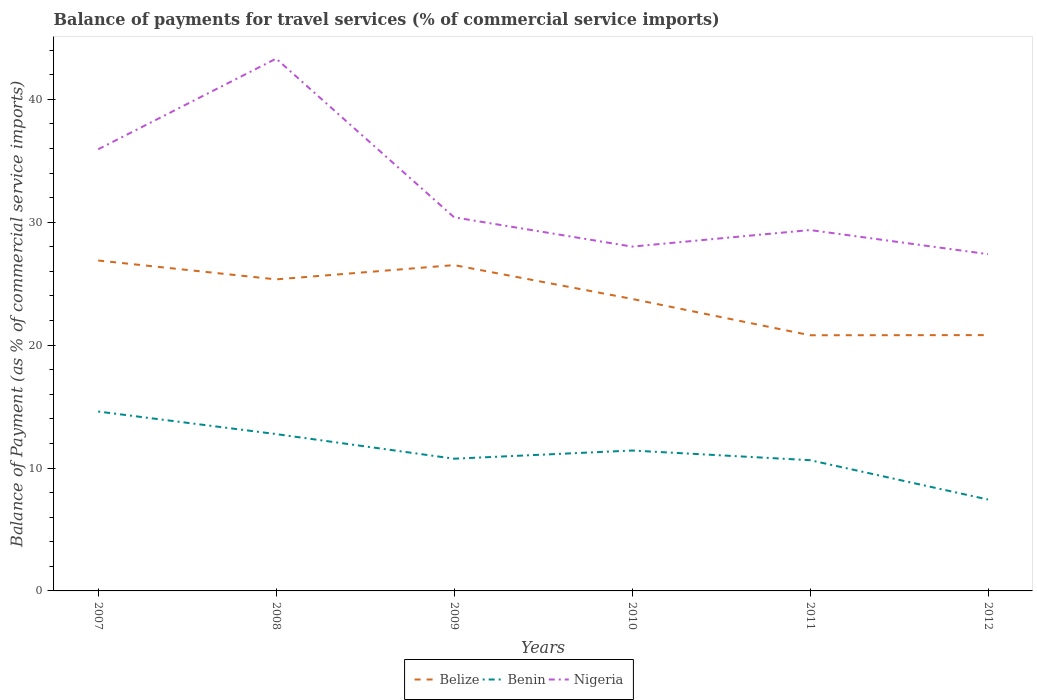How many different coloured lines are there?
Give a very brief answer. 3. Does the line corresponding to Belize intersect with the line corresponding to Benin?
Make the answer very short. No. Across all years, what is the maximum balance of payments for travel services in Benin?
Your response must be concise. 7.44. What is the total balance of payments for travel services in Benin in the graph?
Offer a very short reply. 0.79. What is the difference between the highest and the second highest balance of payments for travel services in Belize?
Keep it short and to the point. 6.08. What is the difference between the highest and the lowest balance of payments for travel services in Benin?
Give a very brief answer. 3. Is the balance of payments for travel services in Benin strictly greater than the balance of payments for travel services in Belize over the years?
Ensure brevity in your answer.  Yes. How many lines are there?
Make the answer very short. 3. What is the difference between two consecutive major ticks on the Y-axis?
Offer a very short reply. 10. How are the legend labels stacked?
Your response must be concise. Horizontal. What is the title of the graph?
Offer a very short reply. Balance of payments for travel services (% of commercial service imports). What is the label or title of the Y-axis?
Give a very brief answer. Balance of Payment (as % of commercial service imports). What is the Balance of Payment (as % of commercial service imports) of Belize in 2007?
Provide a short and direct response. 26.89. What is the Balance of Payment (as % of commercial service imports) in Benin in 2007?
Make the answer very short. 14.6. What is the Balance of Payment (as % of commercial service imports) in Nigeria in 2007?
Your response must be concise. 35.94. What is the Balance of Payment (as % of commercial service imports) of Belize in 2008?
Provide a short and direct response. 25.35. What is the Balance of Payment (as % of commercial service imports) in Benin in 2008?
Your answer should be compact. 12.76. What is the Balance of Payment (as % of commercial service imports) of Nigeria in 2008?
Your answer should be compact. 43.31. What is the Balance of Payment (as % of commercial service imports) in Belize in 2009?
Offer a terse response. 26.51. What is the Balance of Payment (as % of commercial service imports) in Benin in 2009?
Your response must be concise. 10.76. What is the Balance of Payment (as % of commercial service imports) of Nigeria in 2009?
Give a very brief answer. 30.4. What is the Balance of Payment (as % of commercial service imports) in Belize in 2010?
Make the answer very short. 23.76. What is the Balance of Payment (as % of commercial service imports) in Benin in 2010?
Your answer should be compact. 11.42. What is the Balance of Payment (as % of commercial service imports) in Nigeria in 2010?
Your response must be concise. 28.02. What is the Balance of Payment (as % of commercial service imports) of Belize in 2011?
Your answer should be very brief. 20.8. What is the Balance of Payment (as % of commercial service imports) in Benin in 2011?
Keep it short and to the point. 10.64. What is the Balance of Payment (as % of commercial service imports) in Nigeria in 2011?
Provide a short and direct response. 29.37. What is the Balance of Payment (as % of commercial service imports) in Belize in 2012?
Offer a very short reply. 20.82. What is the Balance of Payment (as % of commercial service imports) in Benin in 2012?
Provide a succinct answer. 7.44. What is the Balance of Payment (as % of commercial service imports) of Nigeria in 2012?
Offer a very short reply. 27.4. Across all years, what is the maximum Balance of Payment (as % of commercial service imports) of Belize?
Provide a short and direct response. 26.89. Across all years, what is the maximum Balance of Payment (as % of commercial service imports) of Benin?
Ensure brevity in your answer.  14.6. Across all years, what is the maximum Balance of Payment (as % of commercial service imports) of Nigeria?
Keep it short and to the point. 43.31. Across all years, what is the minimum Balance of Payment (as % of commercial service imports) in Belize?
Give a very brief answer. 20.8. Across all years, what is the minimum Balance of Payment (as % of commercial service imports) in Benin?
Provide a short and direct response. 7.44. Across all years, what is the minimum Balance of Payment (as % of commercial service imports) of Nigeria?
Provide a succinct answer. 27.4. What is the total Balance of Payment (as % of commercial service imports) in Belize in the graph?
Make the answer very short. 144.13. What is the total Balance of Payment (as % of commercial service imports) in Benin in the graph?
Ensure brevity in your answer.  67.62. What is the total Balance of Payment (as % of commercial service imports) of Nigeria in the graph?
Offer a very short reply. 194.43. What is the difference between the Balance of Payment (as % of commercial service imports) in Belize in 2007 and that in 2008?
Ensure brevity in your answer.  1.54. What is the difference between the Balance of Payment (as % of commercial service imports) in Benin in 2007 and that in 2008?
Provide a succinct answer. 1.84. What is the difference between the Balance of Payment (as % of commercial service imports) of Nigeria in 2007 and that in 2008?
Offer a terse response. -7.38. What is the difference between the Balance of Payment (as % of commercial service imports) of Belize in 2007 and that in 2009?
Offer a very short reply. 0.37. What is the difference between the Balance of Payment (as % of commercial service imports) in Benin in 2007 and that in 2009?
Offer a very short reply. 3.84. What is the difference between the Balance of Payment (as % of commercial service imports) of Nigeria in 2007 and that in 2009?
Your answer should be compact. 5.54. What is the difference between the Balance of Payment (as % of commercial service imports) of Belize in 2007 and that in 2010?
Your response must be concise. 3.13. What is the difference between the Balance of Payment (as % of commercial service imports) in Benin in 2007 and that in 2010?
Ensure brevity in your answer.  3.17. What is the difference between the Balance of Payment (as % of commercial service imports) in Nigeria in 2007 and that in 2010?
Give a very brief answer. 7.92. What is the difference between the Balance of Payment (as % of commercial service imports) in Belize in 2007 and that in 2011?
Ensure brevity in your answer.  6.08. What is the difference between the Balance of Payment (as % of commercial service imports) in Benin in 2007 and that in 2011?
Keep it short and to the point. 3.96. What is the difference between the Balance of Payment (as % of commercial service imports) of Nigeria in 2007 and that in 2011?
Make the answer very short. 6.57. What is the difference between the Balance of Payment (as % of commercial service imports) in Belize in 2007 and that in 2012?
Offer a terse response. 6.07. What is the difference between the Balance of Payment (as % of commercial service imports) of Benin in 2007 and that in 2012?
Offer a terse response. 7.16. What is the difference between the Balance of Payment (as % of commercial service imports) of Nigeria in 2007 and that in 2012?
Provide a succinct answer. 8.53. What is the difference between the Balance of Payment (as % of commercial service imports) in Belize in 2008 and that in 2009?
Provide a short and direct response. -1.16. What is the difference between the Balance of Payment (as % of commercial service imports) in Benin in 2008 and that in 2009?
Provide a succinct answer. 2. What is the difference between the Balance of Payment (as % of commercial service imports) in Nigeria in 2008 and that in 2009?
Keep it short and to the point. 12.91. What is the difference between the Balance of Payment (as % of commercial service imports) of Belize in 2008 and that in 2010?
Your answer should be compact. 1.59. What is the difference between the Balance of Payment (as % of commercial service imports) in Benin in 2008 and that in 2010?
Keep it short and to the point. 1.34. What is the difference between the Balance of Payment (as % of commercial service imports) of Nigeria in 2008 and that in 2010?
Offer a very short reply. 15.3. What is the difference between the Balance of Payment (as % of commercial service imports) of Belize in 2008 and that in 2011?
Ensure brevity in your answer.  4.55. What is the difference between the Balance of Payment (as % of commercial service imports) in Benin in 2008 and that in 2011?
Your answer should be very brief. 2.12. What is the difference between the Balance of Payment (as % of commercial service imports) in Nigeria in 2008 and that in 2011?
Your answer should be compact. 13.95. What is the difference between the Balance of Payment (as % of commercial service imports) in Belize in 2008 and that in 2012?
Your answer should be very brief. 4.53. What is the difference between the Balance of Payment (as % of commercial service imports) in Benin in 2008 and that in 2012?
Provide a succinct answer. 5.32. What is the difference between the Balance of Payment (as % of commercial service imports) of Nigeria in 2008 and that in 2012?
Your answer should be compact. 15.91. What is the difference between the Balance of Payment (as % of commercial service imports) of Belize in 2009 and that in 2010?
Provide a short and direct response. 2.75. What is the difference between the Balance of Payment (as % of commercial service imports) of Benin in 2009 and that in 2010?
Ensure brevity in your answer.  -0.67. What is the difference between the Balance of Payment (as % of commercial service imports) in Nigeria in 2009 and that in 2010?
Ensure brevity in your answer.  2.38. What is the difference between the Balance of Payment (as % of commercial service imports) of Belize in 2009 and that in 2011?
Provide a short and direct response. 5.71. What is the difference between the Balance of Payment (as % of commercial service imports) in Benin in 2009 and that in 2011?
Provide a succinct answer. 0.12. What is the difference between the Balance of Payment (as % of commercial service imports) of Nigeria in 2009 and that in 2011?
Offer a terse response. 1.03. What is the difference between the Balance of Payment (as % of commercial service imports) of Belize in 2009 and that in 2012?
Ensure brevity in your answer.  5.7. What is the difference between the Balance of Payment (as % of commercial service imports) of Benin in 2009 and that in 2012?
Offer a very short reply. 3.32. What is the difference between the Balance of Payment (as % of commercial service imports) in Nigeria in 2009 and that in 2012?
Offer a terse response. 3. What is the difference between the Balance of Payment (as % of commercial service imports) in Belize in 2010 and that in 2011?
Keep it short and to the point. 2.96. What is the difference between the Balance of Payment (as % of commercial service imports) of Benin in 2010 and that in 2011?
Provide a succinct answer. 0.79. What is the difference between the Balance of Payment (as % of commercial service imports) in Nigeria in 2010 and that in 2011?
Give a very brief answer. -1.35. What is the difference between the Balance of Payment (as % of commercial service imports) in Belize in 2010 and that in 2012?
Your answer should be compact. 2.94. What is the difference between the Balance of Payment (as % of commercial service imports) in Benin in 2010 and that in 2012?
Your answer should be very brief. 3.99. What is the difference between the Balance of Payment (as % of commercial service imports) of Nigeria in 2010 and that in 2012?
Ensure brevity in your answer.  0.61. What is the difference between the Balance of Payment (as % of commercial service imports) in Belize in 2011 and that in 2012?
Keep it short and to the point. -0.01. What is the difference between the Balance of Payment (as % of commercial service imports) of Benin in 2011 and that in 2012?
Provide a short and direct response. 3.2. What is the difference between the Balance of Payment (as % of commercial service imports) of Nigeria in 2011 and that in 2012?
Give a very brief answer. 1.96. What is the difference between the Balance of Payment (as % of commercial service imports) of Belize in 2007 and the Balance of Payment (as % of commercial service imports) of Benin in 2008?
Give a very brief answer. 14.12. What is the difference between the Balance of Payment (as % of commercial service imports) in Belize in 2007 and the Balance of Payment (as % of commercial service imports) in Nigeria in 2008?
Offer a terse response. -16.43. What is the difference between the Balance of Payment (as % of commercial service imports) in Benin in 2007 and the Balance of Payment (as % of commercial service imports) in Nigeria in 2008?
Keep it short and to the point. -28.72. What is the difference between the Balance of Payment (as % of commercial service imports) in Belize in 2007 and the Balance of Payment (as % of commercial service imports) in Benin in 2009?
Keep it short and to the point. 16.13. What is the difference between the Balance of Payment (as % of commercial service imports) in Belize in 2007 and the Balance of Payment (as % of commercial service imports) in Nigeria in 2009?
Make the answer very short. -3.51. What is the difference between the Balance of Payment (as % of commercial service imports) in Benin in 2007 and the Balance of Payment (as % of commercial service imports) in Nigeria in 2009?
Provide a succinct answer. -15.8. What is the difference between the Balance of Payment (as % of commercial service imports) in Belize in 2007 and the Balance of Payment (as % of commercial service imports) in Benin in 2010?
Ensure brevity in your answer.  15.46. What is the difference between the Balance of Payment (as % of commercial service imports) in Belize in 2007 and the Balance of Payment (as % of commercial service imports) in Nigeria in 2010?
Keep it short and to the point. -1.13. What is the difference between the Balance of Payment (as % of commercial service imports) of Benin in 2007 and the Balance of Payment (as % of commercial service imports) of Nigeria in 2010?
Make the answer very short. -13.42. What is the difference between the Balance of Payment (as % of commercial service imports) of Belize in 2007 and the Balance of Payment (as % of commercial service imports) of Benin in 2011?
Provide a succinct answer. 16.25. What is the difference between the Balance of Payment (as % of commercial service imports) in Belize in 2007 and the Balance of Payment (as % of commercial service imports) in Nigeria in 2011?
Your answer should be compact. -2.48. What is the difference between the Balance of Payment (as % of commercial service imports) of Benin in 2007 and the Balance of Payment (as % of commercial service imports) of Nigeria in 2011?
Keep it short and to the point. -14.77. What is the difference between the Balance of Payment (as % of commercial service imports) of Belize in 2007 and the Balance of Payment (as % of commercial service imports) of Benin in 2012?
Keep it short and to the point. 19.45. What is the difference between the Balance of Payment (as % of commercial service imports) of Belize in 2007 and the Balance of Payment (as % of commercial service imports) of Nigeria in 2012?
Ensure brevity in your answer.  -0.52. What is the difference between the Balance of Payment (as % of commercial service imports) in Benin in 2007 and the Balance of Payment (as % of commercial service imports) in Nigeria in 2012?
Keep it short and to the point. -12.81. What is the difference between the Balance of Payment (as % of commercial service imports) in Belize in 2008 and the Balance of Payment (as % of commercial service imports) in Benin in 2009?
Give a very brief answer. 14.59. What is the difference between the Balance of Payment (as % of commercial service imports) of Belize in 2008 and the Balance of Payment (as % of commercial service imports) of Nigeria in 2009?
Offer a terse response. -5.05. What is the difference between the Balance of Payment (as % of commercial service imports) in Benin in 2008 and the Balance of Payment (as % of commercial service imports) in Nigeria in 2009?
Your answer should be very brief. -17.64. What is the difference between the Balance of Payment (as % of commercial service imports) in Belize in 2008 and the Balance of Payment (as % of commercial service imports) in Benin in 2010?
Offer a terse response. 13.93. What is the difference between the Balance of Payment (as % of commercial service imports) of Belize in 2008 and the Balance of Payment (as % of commercial service imports) of Nigeria in 2010?
Your answer should be compact. -2.67. What is the difference between the Balance of Payment (as % of commercial service imports) in Benin in 2008 and the Balance of Payment (as % of commercial service imports) in Nigeria in 2010?
Offer a terse response. -15.26. What is the difference between the Balance of Payment (as % of commercial service imports) of Belize in 2008 and the Balance of Payment (as % of commercial service imports) of Benin in 2011?
Keep it short and to the point. 14.71. What is the difference between the Balance of Payment (as % of commercial service imports) of Belize in 2008 and the Balance of Payment (as % of commercial service imports) of Nigeria in 2011?
Make the answer very short. -4.02. What is the difference between the Balance of Payment (as % of commercial service imports) of Benin in 2008 and the Balance of Payment (as % of commercial service imports) of Nigeria in 2011?
Offer a terse response. -16.6. What is the difference between the Balance of Payment (as % of commercial service imports) in Belize in 2008 and the Balance of Payment (as % of commercial service imports) in Benin in 2012?
Provide a short and direct response. 17.91. What is the difference between the Balance of Payment (as % of commercial service imports) in Belize in 2008 and the Balance of Payment (as % of commercial service imports) in Nigeria in 2012?
Keep it short and to the point. -2.05. What is the difference between the Balance of Payment (as % of commercial service imports) of Benin in 2008 and the Balance of Payment (as % of commercial service imports) of Nigeria in 2012?
Your response must be concise. -14.64. What is the difference between the Balance of Payment (as % of commercial service imports) of Belize in 2009 and the Balance of Payment (as % of commercial service imports) of Benin in 2010?
Make the answer very short. 15.09. What is the difference between the Balance of Payment (as % of commercial service imports) of Belize in 2009 and the Balance of Payment (as % of commercial service imports) of Nigeria in 2010?
Your answer should be very brief. -1.5. What is the difference between the Balance of Payment (as % of commercial service imports) of Benin in 2009 and the Balance of Payment (as % of commercial service imports) of Nigeria in 2010?
Provide a short and direct response. -17.26. What is the difference between the Balance of Payment (as % of commercial service imports) of Belize in 2009 and the Balance of Payment (as % of commercial service imports) of Benin in 2011?
Ensure brevity in your answer.  15.87. What is the difference between the Balance of Payment (as % of commercial service imports) of Belize in 2009 and the Balance of Payment (as % of commercial service imports) of Nigeria in 2011?
Offer a very short reply. -2.85. What is the difference between the Balance of Payment (as % of commercial service imports) of Benin in 2009 and the Balance of Payment (as % of commercial service imports) of Nigeria in 2011?
Offer a terse response. -18.61. What is the difference between the Balance of Payment (as % of commercial service imports) of Belize in 2009 and the Balance of Payment (as % of commercial service imports) of Benin in 2012?
Offer a very short reply. 19.08. What is the difference between the Balance of Payment (as % of commercial service imports) of Belize in 2009 and the Balance of Payment (as % of commercial service imports) of Nigeria in 2012?
Make the answer very short. -0.89. What is the difference between the Balance of Payment (as % of commercial service imports) of Benin in 2009 and the Balance of Payment (as % of commercial service imports) of Nigeria in 2012?
Offer a terse response. -16.65. What is the difference between the Balance of Payment (as % of commercial service imports) in Belize in 2010 and the Balance of Payment (as % of commercial service imports) in Benin in 2011?
Provide a short and direct response. 13.12. What is the difference between the Balance of Payment (as % of commercial service imports) of Belize in 2010 and the Balance of Payment (as % of commercial service imports) of Nigeria in 2011?
Your answer should be very brief. -5.61. What is the difference between the Balance of Payment (as % of commercial service imports) in Benin in 2010 and the Balance of Payment (as % of commercial service imports) in Nigeria in 2011?
Provide a short and direct response. -17.94. What is the difference between the Balance of Payment (as % of commercial service imports) of Belize in 2010 and the Balance of Payment (as % of commercial service imports) of Benin in 2012?
Keep it short and to the point. 16.32. What is the difference between the Balance of Payment (as % of commercial service imports) in Belize in 2010 and the Balance of Payment (as % of commercial service imports) in Nigeria in 2012?
Provide a succinct answer. -3.64. What is the difference between the Balance of Payment (as % of commercial service imports) in Benin in 2010 and the Balance of Payment (as % of commercial service imports) in Nigeria in 2012?
Keep it short and to the point. -15.98. What is the difference between the Balance of Payment (as % of commercial service imports) in Belize in 2011 and the Balance of Payment (as % of commercial service imports) in Benin in 2012?
Make the answer very short. 13.37. What is the difference between the Balance of Payment (as % of commercial service imports) in Belize in 2011 and the Balance of Payment (as % of commercial service imports) in Nigeria in 2012?
Your response must be concise. -6.6. What is the difference between the Balance of Payment (as % of commercial service imports) in Benin in 2011 and the Balance of Payment (as % of commercial service imports) in Nigeria in 2012?
Your response must be concise. -16.77. What is the average Balance of Payment (as % of commercial service imports) in Belize per year?
Ensure brevity in your answer.  24.02. What is the average Balance of Payment (as % of commercial service imports) in Benin per year?
Your answer should be very brief. 11.27. What is the average Balance of Payment (as % of commercial service imports) in Nigeria per year?
Provide a short and direct response. 32.41. In the year 2007, what is the difference between the Balance of Payment (as % of commercial service imports) in Belize and Balance of Payment (as % of commercial service imports) in Benin?
Ensure brevity in your answer.  12.29. In the year 2007, what is the difference between the Balance of Payment (as % of commercial service imports) of Belize and Balance of Payment (as % of commercial service imports) of Nigeria?
Make the answer very short. -9.05. In the year 2007, what is the difference between the Balance of Payment (as % of commercial service imports) in Benin and Balance of Payment (as % of commercial service imports) in Nigeria?
Provide a short and direct response. -21.34. In the year 2008, what is the difference between the Balance of Payment (as % of commercial service imports) of Belize and Balance of Payment (as % of commercial service imports) of Benin?
Give a very brief answer. 12.59. In the year 2008, what is the difference between the Balance of Payment (as % of commercial service imports) in Belize and Balance of Payment (as % of commercial service imports) in Nigeria?
Ensure brevity in your answer.  -17.96. In the year 2008, what is the difference between the Balance of Payment (as % of commercial service imports) in Benin and Balance of Payment (as % of commercial service imports) in Nigeria?
Make the answer very short. -30.55. In the year 2009, what is the difference between the Balance of Payment (as % of commercial service imports) of Belize and Balance of Payment (as % of commercial service imports) of Benin?
Offer a very short reply. 15.75. In the year 2009, what is the difference between the Balance of Payment (as % of commercial service imports) in Belize and Balance of Payment (as % of commercial service imports) in Nigeria?
Ensure brevity in your answer.  -3.89. In the year 2009, what is the difference between the Balance of Payment (as % of commercial service imports) of Benin and Balance of Payment (as % of commercial service imports) of Nigeria?
Offer a very short reply. -19.64. In the year 2010, what is the difference between the Balance of Payment (as % of commercial service imports) in Belize and Balance of Payment (as % of commercial service imports) in Benin?
Provide a succinct answer. 12.34. In the year 2010, what is the difference between the Balance of Payment (as % of commercial service imports) of Belize and Balance of Payment (as % of commercial service imports) of Nigeria?
Provide a succinct answer. -4.26. In the year 2010, what is the difference between the Balance of Payment (as % of commercial service imports) of Benin and Balance of Payment (as % of commercial service imports) of Nigeria?
Provide a short and direct response. -16.59. In the year 2011, what is the difference between the Balance of Payment (as % of commercial service imports) in Belize and Balance of Payment (as % of commercial service imports) in Benin?
Offer a terse response. 10.16. In the year 2011, what is the difference between the Balance of Payment (as % of commercial service imports) of Belize and Balance of Payment (as % of commercial service imports) of Nigeria?
Ensure brevity in your answer.  -8.56. In the year 2011, what is the difference between the Balance of Payment (as % of commercial service imports) in Benin and Balance of Payment (as % of commercial service imports) in Nigeria?
Offer a terse response. -18.73. In the year 2012, what is the difference between the Balance of Payment (as % of commercial service imports) in Belize and Balance of Payment (as % of commercial service imports) in Benin?
Give a very brief answer. 13.38. In the year 2012, what is the difference between the Balance of Payment (as % of commercial service imports) of Belize and Balance of Payment (as % of commercial service imports) of Nigeria?
Ensure brevity in your answer.  -6.59. In the year 2012, what is the difference between the Balance of Payment (as % of commercial service imports) in Benin and Balance of Payment (as % of commercial service imports) in Nigeria?
Ensure brevity in your answer.  -19.97. What is the ratio of the Balance of Payment (as % of commercial service imports) of Belize in 2007 to that in 2008?
Keep it short and to the point. 1.06. What is the ratio of the Balance of Payment (as % of commercial service imports) of Benin in 2007 to that in 2008?
Ensure brevity in your answer.  1.14. What is the ratio of the Balance of Payment (as % of commercial service imports) in Nigeria in 2007 to that in 2008?
Provide a short and direct response. 0.83. What is the ratio of the Balance of Payment (as % of commercial service imports) of Belize in 2007 to that in 2009?
Your answer should be compact. 1.01. What is the ratio of the Balance of Payment (as % of commercial service imports) of Benin in 2007 to that in 2009?
Provide a short and direct response. 1.36. What is the ratio of the Balance of Payment (as % of commercial service imports) of Nigeria in 2007 to that in 2009?
Keep it short and to the point. 1.18. What is the ratio of the Balance of Payment (as % of commercial service imports) in Belize in 2007 to that in 2010?
Your answer should be very brief. 1.13. What is the ratio of the Balance of Payment (as % of commercial service imports) in Benin in 2007 to that in 2010?
Give a very brief answer. 1.28. What is the ratio of the Balance of Payment (as % of commercial service imports) of Nigeria in 2007 to that in 2010?
Your answer should be compact. 1.28. What is the ratio of the Balance of Payment (as % of commercial service imports) of Belize in 2007 to that in 2011?
Provide a succinct answer. 1.29. What is the ratio of the Balance of Payment (as % of commercial service imports) in Benin in 2007 to that in 2011?
Make the answer very short. 1.37. What is the ratio of the Balance of Payment (as % of commercial service imports) of Nigeria in 2007 to that in 2011?
Give a very brief answer. 1.22. What is the ratio of the Balance of Payment (as % of commercial service imports) of Belize in 2007 to that in 2012?
Offer a very short reply. 1.29. What is the ratio of the Balance of Payment (as % of commercial service imports) in Benin in 2007 to that in 2012?
Offer a terse response. 1.96. What is the ratio of the Balance of Payment (as % of commercial service imports) of Nigeria in 2007 to that in 2012?
Provide a succinct answer. 1.31. What is the ratio of the Balance of Payment (as % of commercial service imports) in Belize in 2008 to that in 2009?
Offer a very short reply. 0.96. What is the ratio of the Balance of Payment (as % of commercial service imports) in Benin in 2008 to that in 2009?
Offer a very short reply. 1.19. What is the ratio of the Balance of Payment (as % of commercial service imports) in Nigeria in 2008 to that in 2009?
Keep it short and to the point. 1.42. What is the ratio of the Balance of Payment (as % of commercial service imports) in Belize in 2008 to that in 2010?
Offer a terse response. 1.07. What is the ratio of the Balance of Payment (as % of commercial service imports) in Benin in 2008 to that in 2010?
Ensure brevity in your answer.  1.12. What is the ratio of the Balance of Payment (as % of commercial service imports) in Nigeria in 2008 to that in 2010?
Offer a terse response. 1.55. What is the ratio of the Balance of Payment (as % of commercial service imports) in Belize in 2008 to that in 2011?
Your response must be concise. 1.22. What is the ratio of the Balance of Payment (as % of commercial service imports) of Benin in 2008 to that in 2011?
Provide a succinct answer. 1.2. What is the ratio of the Balance of Payment (as % of commercial service imports) of Nigeria in 2008 to that in 2011?
Make the answer very short. 1.48. What is the ratio of the Balance of Payment (as % of commercial service imports) of Belize in 2008 to that in 2012?
Your answer should be very brief. 1.22. What is the ratio of the Balance of Payment (as % of commercial service imports) in Benin in 2008 to that in 2012?
Keep it short and to the point. 1.72. What is the ratio of the Balance of Payment (as % of commercial service imports) in Nigeria in 2008 to that in 2012?
Your answer should be very brief. 1.58. What is the ratio of the Balance of Payment (as % of commercial service imports) in Belize in 2009 to that in 2010?
Make the answer very short. 1.12. What is the ratio of the Balance of Payment (as % of commercial service imports) in Benin in 2009 to that in 2010?
Make the answer very short. 0.94. What is the ratio of the Balance of Payment (as % of commercial service imports) of Nigeria in 2009 to that in 2010?
Your answer should be compact. 1.08. What is the ratio of the Balance of Payment (as % of commercial service imports) of Belize in 2009 to that in 2011?
Offer a terse response. 1.27. What is the ratio of the Balance of Payment (as % of commercial service imports) of Benin in 2009 to that in 2011?
Keep it short and to the point. 1.01. What is the ratio of the Balance of Payment (as % of commercial service imports) of Nigeria in 2009 to that in 2011?
Offer a terse response. 1.04. What is the ratio of the Balance of Payment (as % of commercial service imports) in Belize in 2009 to that in 2012?
Offer a very short reply. 1.27. What is the ratio of the Balance of Payment (as % of commercial service imports) of Benin in 2009 to that in 2012?
Ensure brevity in your answer.  1.45. What is the ratio of the Balance of Payment (as % of commercial service imports) of Nigeria in 2009 to that in 2012?
Offer a terse response. 1.11. What is the ratio of the Balance of Payment (as % of commercial service imports) in Belize in 2010 to that in 2011?
Make the answer very short. 1.14. What is the ratio of the Balance of Payment (as % of commercial service imports) in Benin in 2010 to that in 2011?
Provide a succinct answer. 1.07. What is the ratio of the Balance of Payment (as % of commercial service imports) of Nigeria in 2010 to that in 2011?
Your response must be concise. 0.95. What is the ratio of the Balance of Payment (as % of commercial service imports) of Belize in 2010 to that in 2012?
Make the answer very short. 1.14. What is the ratio of the Balance of Payment (as % of commercial service imports) in Benin in 2010 to that in 2012?
Ensure brevity in your answer.  1.54. What is the ratio of the Balance of Payment (as % of commercial service imports) in Nigeria in 2010 to that in 2012?
Give a very brief answer. 1.02. What is the ratio of the Balance of Payment (as % of commercial service imports) in Belize in 2011 to that in 2012?
Your response must be concise. 1. What is the ratio of the Balance of Payment (as % of commercial service imports) in Benin in 2011 to that in 2012?
Offer a very short reply. 1.43. What is the ratio of the Balance of Payment (as % of commercial service imports) in Nigeria in 2011 to that in 2012?
Your answer should be compact. 1.07. What is the difference between the highest and the second highest Balance of Payment (as % of commercial service imports) in Belize?
Your answer should be very brief. 0.37. What is the difference between the highest and the second highest Balance of Payment (as % of commercial service imports) in Benin?
Your answer should be very brief. 1.84. What is the difference between the highest and the second highest Balance of Payment (as % of commercial service imports) in Nigeria?
Make the answer very short. 7.38. What is the difference between the highest and the lowest Balance of Payment (as % of commercial service imports) of Belize?
Keep it short and to the point. 6.08. What is the difference between the highest and the lowest Balance of Payment (as % of commercial service imports) of Benin?
Provide a succinct answer. 7.16. What is the difference between the highest and the lowest Balance of Payment (as % of commercial service imports) in Nigeria?
Your answer should be very brief. 15.91. 